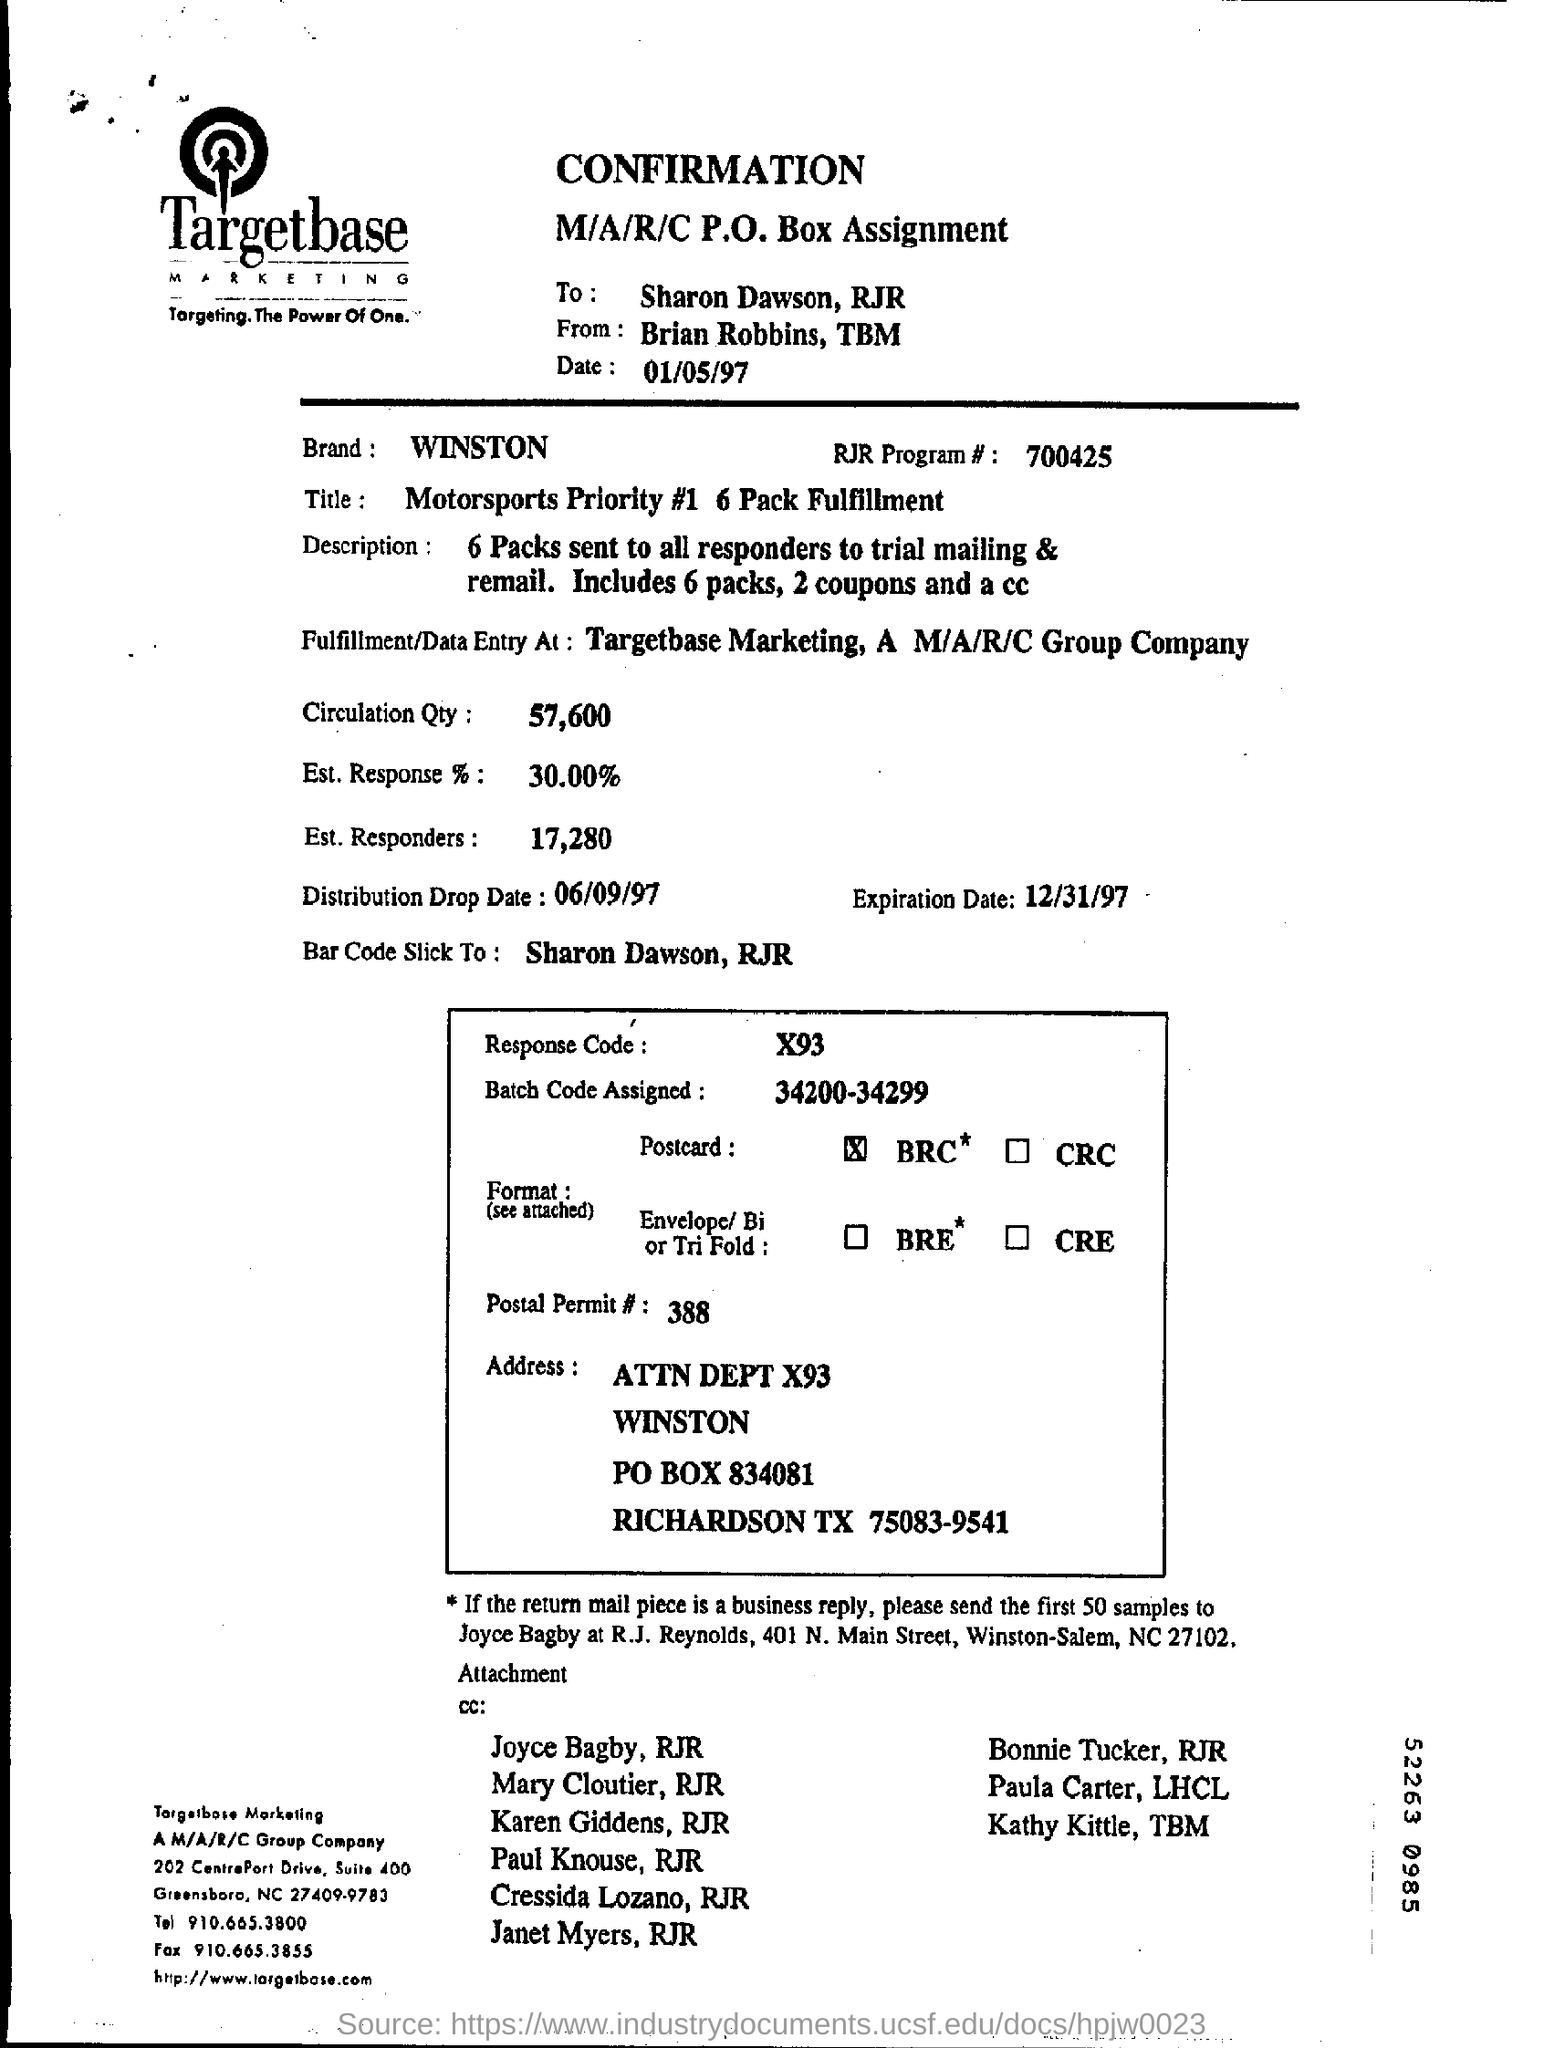Who is this from?
Offer a very short reply. Brian Robbins. To whom is this document addressed ?
Your answer should be compact. Sharon Dawson,RJR. What is the Distribution Drop Date ?
Ensure brevity in your answer.  06/09/97. Which Batch Code is Assigned ?
Keep it short and to the point. 34200-34299. What is the Response Code ?
Offer a very short reply. X93. 